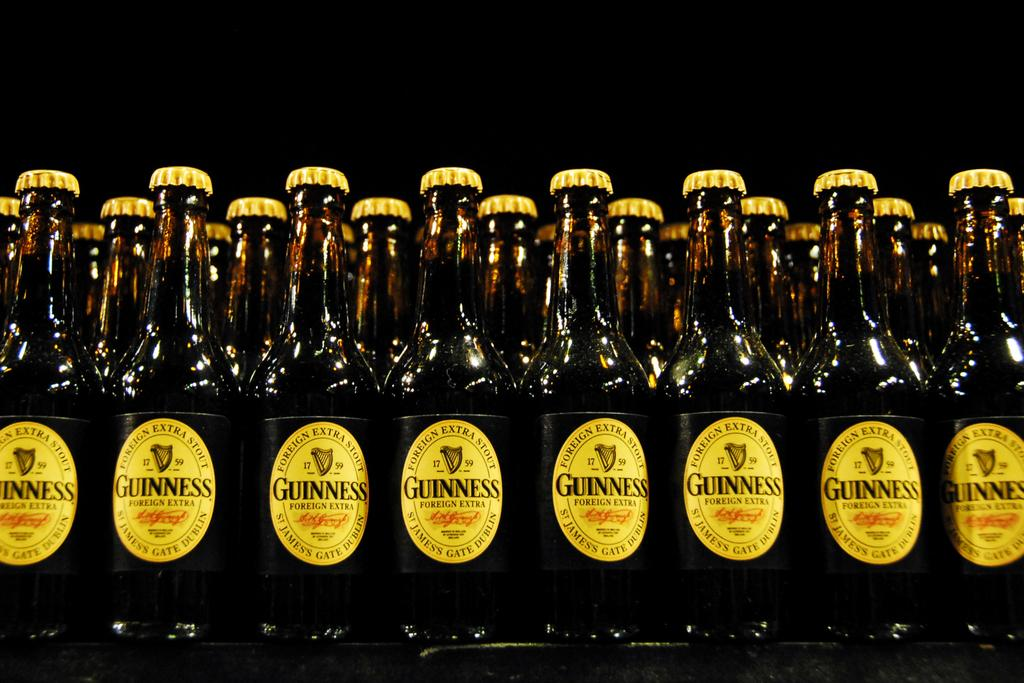<image>
Summarize the visual content of the image. A collection of yellow labeled Guinness bottles sitting together. 